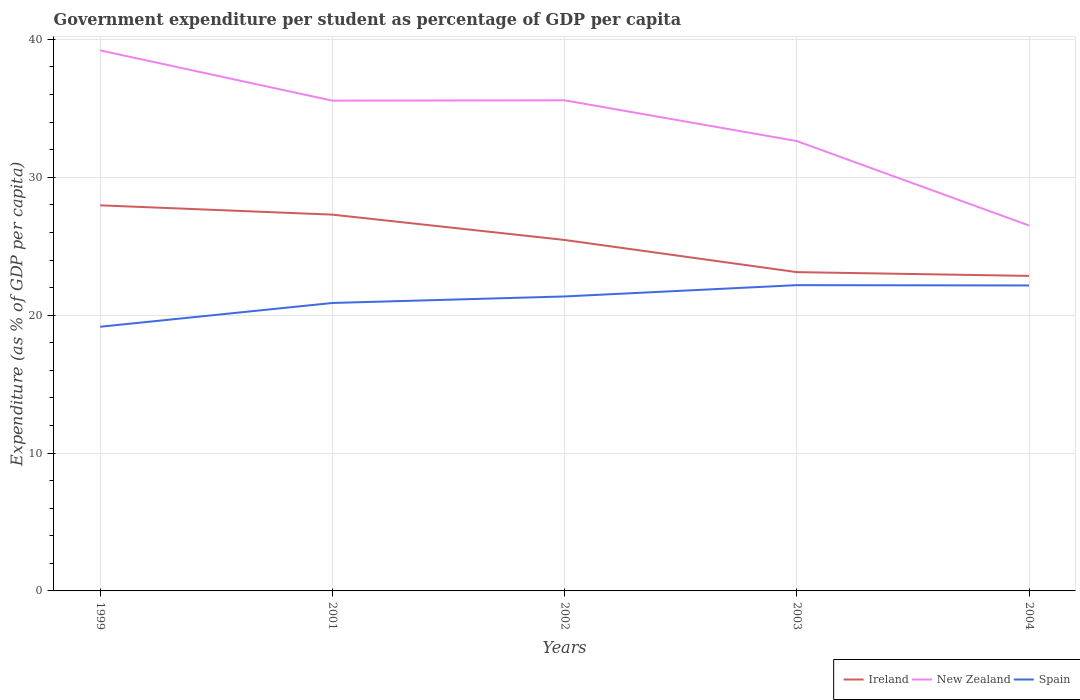How many different coloured lines are there?
Your response must be concise. 3. Across all years, what is the maximum percentage of expenditure per student in Ireland?
Ensure brevity in your answer.  22.85. In which year was the percentage of expenditure per student in Ireland maximum?
Provide a short and direct response. 2004. What is the total percentage of expenditure per student in Spain in the graph?
Ensure brevity in your answer.  0.02. What is the difference between the highest and the second highest percentage of expenditure per student in Spain?
Give a very brief answer. 3.02. What is the difference between the highest and the lowest percentage of expenditure per student in New Zealand?
Offer a very short reply. 3. Is the percentage of expenditure per student in New Zealand strictly greater than the percentage of expenditure per student in Spain over the years?
Keep it short and to the point. No. How many lines are there?
Ensure brevity in your answer.  3. What is the difference between two consecutive major ticks on the Y-axis?
Give a very brief answer. 10. Where does the legend appear in the graph?
Give a very brief answer. Bottom right. How many legend labels are there?
Make the answer very short. 3. What is the title of the graph?
Ensure brevity in your answer.  Government expenditure per student as percentage of GDP per capita. What is the label or title of the X-axis?
Your response must be concise. Years. What is the label or title of the Y-axis?
Your answer should be very brief. Expenditure (as % of GDP per capita). What is the Expenditure (as % of GDP per capita) in Ireland in 1999?
Make the answer very short. 27.97. What is the Expenditure (as % of GDP per capita) in New Zealand in 1999?
Provide a short and direct response. 39.2. What is the Expenditure (as % of GDP per capita) in Spain in 1999?
Offer a very short reply. 19.16. What is the Expenditure (as % of GDP per capita) of Ireland in 2001?
Ensure brevity in your answer.  27.29. What is the Expenditure (as % of GDP per capita) in New Zealand in 2001?
Make the answer very short. 35.56. What is the Expenditure (as % of GDP per capita) of Spain in 2001?
Your response must be concise. 20.88. What is the Expenditure (as % of GDP per capita) in Ireland in 2002?
Give a very brief answer. 25.45. What is the Expenditure (as % of GDP per capita) of New Zealand in 2002?
Provide a succinct answer. 35.58. What is the Expenditure (as % of GDP per capita) of Spain in 2002?
Offer a terse response. 21.36. What is the Expenditure (as % of GDP per capita) in Ireland in 2003?
Offer a very short reply. 23.12. What is the Expenditure (as % of GDP per capita) in New Zealand in 2003?
Provide a short and direct response. 32.63. What is the Expenditure (as % of GDP per capita) of Spain in 2003?
Keep it short and to the point. 22.18. What is the Expenditure (as % of GDP per capita) in Ireland in 2004?
Make the answer very short. 22.85. What is the Expenditure (as % of GDP per capita) in New Zealand in 2004?
Your answer should be compact. 26.5. What is the Expenditure (as % of GDP per capita) of Spain in 2004?
Your answer should be very brief. 22.16. Across all years, what is the maximum Expenditure (as % of GDP per capita) of Ireland?
Keep it short and to the point. 27.97. Across all years, what is the maximum Expenditure (as % of GDP per capita) in New Zealand?
Provide a succinct answer. 39.2. Across all years, what is the maximum Expenditure (as % of GDP per capita) of Spain?
Your answer should be compact. 22.18. Across all years, what is the minimum Expenditure (as % of GDP per capita) of Ireland?
Keep it short and to the point. 22.85. Across all years, what is the minimum Expenditure (as % of GDP per capita) in New Zealand?
Keep it short and to the point. 26.5. Across all years, what is the minimum Expenditure (as % of GDP per capita) of Spain?
Keep it short and to the point. 19.16. What is the total Expenditure (as % of GDP per capita) of Ireland in the graph?
Offer a very short reply. 126.68. What is the total Expenditure (as % of GDP per capita) of New Zealand in the graph?
Give a very brief answer. 169.47. What is the total Expenditure (as % of GDP per capita) in Spain in the graph?
Provide a succinct answer. 105.73. What is the difference between the Expenditure (as % of GDP per capita) in Ireland in 1999 and that in 2001?
Offer a terse response. 0.67. What is the difference between the Expenditure (as % of GDP per capita) of New Zealand in 1999 and that in 2001?
Provide a short and direct response. 3.65. What is the difference between the Expenditure (as % of GDP per capita) of Spain in 1999 and that in 2001?
Your answer should be compact. -1.72. What is the difference between the Expenditure (as % of GDP per capita) of Ireland in 1999 and that in 2002?
Your response must be concise. 2.51. What is the difference between the Expenditure (as % of GDP per capita) of New Zealand in 1999 and that in 2002?
Your answer should be very brief. 3.62. What is the difference between the Expenditure (as % of GDP per capita) of Spain in 1999 and that in 2002?
Offer a terse response. -2.2. What is the difference between the Expenditure (as % of GDP per capita) in Ireland in 1999 and that in 2003?
Offer a terse response. 4.84. What is the difference between the Expenditure (as % of GDP per capita) in New Zealand in 1999 and that in 2003?
Provide a short and direct response. 6.58. What is the difference between the Expenditure (as % of GDP per capita) in Spain in 1999 and that in 2003?
Provide a succinct answer. -3.02. What is the difference between the Expenditure (as % of GDP per capita) in Ireland in 1999 and that in 2004?
Make the answer very short. 5.12. What is the difference between the Expenditure (as % of GDP per capita) of New Zealand in 1999 and that in 2004?
Provide a short and direct response. 12.7. What is the difference between the Expenditure (as % of GDP per capita) in Spain in 1999 and that in 2004?
Provide a succinct answer. -2.99. What is the difference between the Expenditure (as % of GDP per capita) in Ireland in 2001 and that in 2002?
Your answer should be very brief. 1.84. What is the difference between the Expenditure (as % of GDP per capita) of New Zealand in 2001 and that in 2002?
Your response must be concise. -0.03. What is the difference between the Expenditure (as % of GDP per capita) in Spain in 2001 and that in 2002?
Offer a very short reply. -0.47. What is the difference between the Expenditure (as % of GDP per capita) of Ireland in 2001 and that in 2003?
Your answer should be very brief. 4.17. What is the difference between the Expenditure (as % of GDP per capita) in New Zealand in 2001 and that in 2003?
Offer a terse response. 2.93. What is the difference between the Expenditure (as % of GDP per capita) in Spain in 2001 and that in 2003?
Your answer should be compact. -1.29. What is the difference between the Expenditure (as % of GDP per capita) of Ireland in 2001 and that in 2004?
Provide a succinct answer. 4.44. What is the difference between the Expenditure (as % of GDP per capita) of New Zealand in 2001 and that in 2004?
Give a very brief answer. 9.06. What is the difference between the Expenditure (as % of GDP per capita) in Spain in 2001 and that in 2004?
Offer a very short reply. -1.27. What is the difference between the Expenditure (as % of GDP per capita) in Ireland in 2002 and that in 2003?
Provide a succinct answer. 2.33. What is the difference between the Expenditure (as % of GDP per capita) of New Zealand in 2002 and that in 2003?
Your answer should be compact. 2.96. What is the difference between the Expenditure (as % of GDP per capita) of Spain in 2002 and that in 2003?
Your response must be concise. -0.82. What is the difference between the Expenditure (as % of GDP per capita) in Ireland in 2002 and that in 2004?
Your answer should be compact. 2.61. What is the difference between the Expenditure (as % of GDP per capita) of New Zealand in 2002 and that in 2004?
Give a very brief answer. 9.08. What is the difference between the Expenditure (as % of GDP per capita) of Spain in 2002 and that in 2004?
Keep it short and to the point. -0.8. What is the difference between the Expenditure (as % of GDP per capita) of Ireland in 2003 and that in 2004?
Your response must be concise. 0.27. What is the difference between the Expenditure (as % of GDP per capita) of New Zealand in 2003 and that in 2004?
Ensure brevity in your answer.  6.12. What is the difference between the Expenditure (as % of GDP per capita) in Spain in 2003 and that in 2004?
Keep it short and to the point. 0.02. What is the difference between the Expenditure (as % of GDP per capita) of Ireland in 1999 and the Expenditure (as % of GDP per capita) of New Zealand in 2001?
Your answer should be very brief. -7.59. What is the difference between the Expenditure (as % of GDP per capita) of Ireland in 1999 and the Expenditure (as % of GDP per capita) of Spain in 2001?
Offer a terse response. 7.08. What is the difference between the Expenditure (as % of GDP per capita) of New Zealand in 1999 and the Expenditure (as % of GDP per capita) of Spain in 2001?
Your response must be concise. 18.32. What is the difference between the Expenditure (as % of GDP per capita) in Ireland in 1999 and the Expenditure (as % of GDP per capita) in New Zealand in 2002?
Your answer should be very brief. -7.62. What is the difference between the Expenditure (as % of GDP per capita) in Ireland in 1999 and the Expenditure (as % of GDP per capita) in Spain in 2002?
Your response must be concise. 6.61. What is the difference between the Expenditure (as % of GDP per capita) in New Zealand in 1999 and the Expenditure (as % of GDP per capita) in Spain in 2002?
Offer a terse response. 17.85. What is the difference between the Expenditure (as % of GDP per capita) of Ireland in 1999 and the Expenditure (as % of GDP per capita) of New Zealand in 2003?
Ensure brevity in your answer.  -4.66. What is the difference between the Expenditure (as % of GDP per capita) in Ireland in 1999 and the Expenditure (as % of GDP per capita) in Spain in 2003?
Your response must be concise. 5.79. What is the difference between the Expenditure (as % of GDP per capita) in New Zealand in 1999 and the Expenditure (as % of GDP per capita) in Spain in 2003?
Offer a very short reply. 17.03. What is the difference between the Expenditure (as % of GDP per capita) of Ireland in 1999 and the Expenditure (as % of GDP per capita) of New Zealand in 2004?
Keep it short and to the point. 1.46. What is the difference between the Expenditure (as % of GDP per capita) of Ireland in 1999 and the Expenditure (as % of GDP per capita) of Spain in 2004?
Make the answer very short. 5.81. What is the difference between the Expenditure (as % of GDP per capita) of New Zealand in 1999 and the Expenditure (as % of GDP per capita) of Spain in 2004?
Your response must be concise. 17.05. What is the difference between the Expenditure (as % of GDP per capita) in Ireland in 2001 and the Expenditure (as % of GDP per capita) in New Zealand in 2002?
Offer a terse response. -8.29. What is the difference between the Expenditure (as % of GDP per capita) of Ireland in 2001 and the Expenditure (as % of GDP per capita) of Spain in 2002?
Keep it short and to the point. 5.93. What is the difference between the Expenditure (as % of GDP per capita) of New Zealand in 2001 and the Expenditure (as % of GDP per capita) of Spain in 2002?
Provide a succinct answer. 14.2. What is the difference between the Expenditure (as % of GDP per capita) of Ireland in 2001 and the Expenditure (as % of GDP per capita) of New Zealand in 2003?
Give a very brief answer. -5.34. What is the difference between the Expenditure (as % of GDP per capita) in Ireland in 2001 and the Expenditure (as % of GDP per capita) in Spain in 2003?
Provide a short and direct response. 5.11. What is the difference between the Expenditure (as % of GDP per capita) of New Zealand in 2001 and the Expenditure (as % of GDP per capita) of Spain in 2003?
Provide a succinct answer. 13.38. What is the difference between the Expenditure (as % of GDP per capita) of Ireland in 2001 and the Expenditure (as % of GDP per capita) of New Zealand in 2004?
Keep it short and to the point. 0.79. What is the difference between the Expenditure (as % of GDP per capita) of Ireland in 2001 and the Expenditure (as % of GDP per capita) of Spain in 2004?
Provide a short and direct response. 5.14. What is the difference between the Expenditure (as % of GDP per capita) of New Zealand in 2001 and the Expenditure (as % of GDP per capita) of Spain in 2004?
Provide a succinct answer. 13.4. What is the difference between the Expenditure (as % of GDP per capita) in Ireland in 2002 and the Expenditure (as % of GDP per capita) in New Zealand in 2003?
Give a very brief answer. -7.17. What is the difference between the Expenditure (as % of GDP per capita) in Ireland in 2002 and the Expenditure (as % of GDP per capita) in Spain in 2003?
Offer a very short reply. 3.28. What is the difference between the Expenditure (as % of GDP per capita) of New Zealand in 2002 and the Expenditure (as % of GDP per capita) of Spain in 2003?
Provide a short and direct response. 13.41. What is the difference between the Expenditure (as % of GDP per capita) of Ireland in 2002 and the Expenditure (as % of GDP per capita) of New Zealand in 2004?
Provide a succinct answer. -1.05. What is the difference between the Expenditure (as % of GDP per capita) in Ireland in 2002 and the Expenditure (as % of GDP per capita) in Spain in 2004?
Ensure brevity in your answer.  3.3. What is the difference between the Expenditure (as % of GDP per capita) of New Zealand in 2002 and the Expenditure (as % of GDP per capita) of Spain in 2004?
Provide a short and direct response. 13.43. What is the difference between the Expenditure (as % of GDP per capita) in Ireland in 2003 and the Expenditure (as % of GDP per capita) in New Zealand in 2004?
Provide a short and direct response. -3.38. What is the difference between the Expenditure (as % of GDP per capita) of Ireland in 2003 and the Expenditure (as % of GDP per capita) of Spain in 2004?
Make the answer very short. 0.97. What is the difference between the Expenditure (as % of GDP per capita) of New Zealand in 2003 and the Expenditure (as % of GDP per capita) of Spain in 2004?
Provide a succinct answer. 10.47. What is the average Expenditure (as % of GDP per capita) of Ireland per year?
Give a very brief answer. 25.34. What is the average Expenditure (as % of GDP per capita) of New Zealand per year?
Offer a very short reply. 33.89. What is the average Expenditure (as % of GDP per capita) in Spain per year?
Make the answer very short. 21.15. In the year 1999, what is the difference between the Expenditure (as % of GDP per capita) in Ireland and Expenditure (as % of GDP per capita) in New Zealand?
Your answer should be very brief. -11.24. In the year 1999, what is the difference between the Expenditure (as % of GDP per capita) of Ireland and Expenditure (as % of GDP per capita) of Spain?
Provide a succinct answer. 8.81. In the year 1999, what is the difference between the Expenditure (as % of GDP per capita) of New Zealand and Expenditure (as % of GDP per capita) of Spain?
Offer a very short reply. 20.04. In the year 2001, what is the difference between the Expenditure (as % of GDP per capita) of Ireland and Expenditure (as % of GDP per capita) of New Zealand?
Your response must be concise. -8.27. In the year 2001, what is the difference between the Expenditure (as % of GDP per capita) in Ireland and Expenditure (as % of GDP per capita) in Spain?
Ensure brevity in your answer.  6.41. In the year 2001, what is the difference between the Expenditure (as % of GDP per capita) of New Zealand and Expenditure (as % of GDP per capita) of Spain?
Your answer should be very brief. 14.67. In the year 2002, what is the difference between the Expenditure (as % of GDP per capita) of Ireland and Expenditure (as % of GDP per capita) of New Zealand?
Ensure brevity in your answer.  -10.13. In the year 2002, what is the difference between the Expenditure (as % of GDP per capita) in Ireland and Expenditure (as % of GDP per capita) in Spain?
Give a very brief answer. 4.1. In the year 2002, what is the difference between the Expenditure (as % of GDP per capita) of New Zealand and Expenditure (as % of GDP per capita) of Spain?
Your answer should be compact. 14.23. In the year 2003, what is the difference between the Expenditure (as % of GDP per capita) of Ireland and Expenditure (as % of GDP per capita) of New Zealand?
Give a very brief answer. -9.51. In the year 2003, what is the difference between the Expenditure (as % of GDP per capita) of Ireland and Expenditure (as % of GDP per capita) of Spain?
Provide a succinct answer. 0.94. In the year 2003, what is the difference between the Expenditure (as % of GDP per capita) of New Zealand and Expenditure (as % of GDP per capita) of Spain?
Provide a succinct answer. 10.45. In the year 2004, what is the difference between the Expenditure (as % of GDP per capita) of Ireland and Expenditure (as % of GDP per capita) of New Zealand?
Your answer should be compact. -3.65. In the year 2004, what is the difference between the Expenditure (as % of GDP per capita) in Ireland and Expenditure (as % of GDP per capita) in Spain?
Keep it short and to the point. 0.69. In the year 2004, what is the difference between the Expenditure (as % of GDP per capita) in New Zealand and Expenditure (as % of GDP per capita) in Spain?
Offer a very short reply. 4.35. What is the ratio of the Expenditure (as % of GDP per capita) in Ireland in 1999 to that in 2001?
Your response must be concise. 1.02. What is the ratio of the Expenditure (as % of GDP per capita) of New Zealand in 1999 to that in 2001?
Your answer should be compact. 1.1. What is the ratio of the Expenditure (as % of GDP per capita) of Spain in 1999 to that in 2001?
Your response must be concise. 0.92. What is the ratio of the Expenditure (as % of GDP per capita) of Ireland in 1999 to that in 2002?
Your answer should be very brief. 1.1. What is the ratio of the Expenditure (as % of GDP per capita) in New Zealand in 1999 to that in 2002?
Offer a terse response. 1.1. What is the ratio of the Expenditure (as % of GDP per capita) of Spain in 1999 to that in 2002?
Your answer should be very brief. 0.9. What is the ratio of the Expenditure (as % of GDP per capita) in Ireland in 1999 to that in 2003?
Your answer should be compact. 1.21. What is the ratio of the Expenditure (as % of GDP per capita) of New Zealand in 1999 to that in 2003?
Ensure brevity in your answer.  1.2. What is the ratio of the Expenditure (as % of GDP per capita) in Spain in 1999 to that in 2003?
Keep it short and to the point. 0.86. What is the ratio of the Expenditure (as % of GDP per capita) in Ireland in 1999 to that in 2004?
Provide a short and direct response. 1.22. What is the ratio of the Expenditure (as % of GDP per capita) in New Zealand in 1999 to that in 2004?
Ensure brevity in your answer.  1.48. What is the ratio of the Expenditure (as % of GDP per capita) in Spain in 1999 to that in 2004?
Offer a very short reply. 0.86. What is the ratio of the Expenditure (as % of GDP per capita) in Ireland in 2001 to that in 2002?
Make the answer very short. 1.07. What is the ratio of the Expenditure (as % of GDP per capita) in New Zealand in 2001 to that in 2002?
Provide a succinct answer. 1. What is the ratio of the Expenditure (as % of GDP per capita) in Spain in 2001 to that in 2002?
Provide a succinct answer. 0.98. What is the ratio of the Expenditure (as % of GDP per capita) of Ireland in 2001 to that in 2003?
Offer a terse response. 1.18. What is the ratio of the Expenditure (as % of GDP per capita) in New Zealand in 2001 to that in 2003?
Your answer should be very brief. 1.09. What is the ratio of the Expenditure (as % of GDP per capita) in Spain in 2001 to that in 2003?
Ensure brevity in your answer.  0.94. What is the ratio of the Expenditure (as % of GDP per capita) of Ireland in 2001 to that in 2004?
Offer a very short reply. 1.19. What is the ratio of the Expenditure (as % of GDP per capita) in New Zealand in 2001 to that in 2004?
Offer a very short reply. 1.34. What is the ratio of the Expenditure (as % of GDP per capita) in Spain in 2001 to that in 2004?
Make the answer very short. 0.94. What is the ratio of the Expenditure (as % of GDP per capita) in Ireland in 2002 to that in 2003?
Your answer should be compact. 1.1. What is the ratio of the Expenditure (as % of GDP per capita) in New Zealand in 2002 to that in 2003?
Give a very brief answer. 1.09. What is the ratio of the Expenditure (as % of GDP per capita) of Spain in 2002 to that in 2003?
Ensure brevity in your answer.  0.96. What is the ratio of the Expenditure (as % of GDP per capita) in Ireland in 2002 to that in 2004?
Make the answer very short. 1.11. What is the ratio of the Expenditure (as % of GDP per capita) in New Zealand in 2002 to that in 2004?
Your answer should be very brief. 1.34. What is the ratio of the Expenditure (as % of GDP per capita) in Ireland in 2003 to that in 2004?
Keep it short and to the point. 1.01. What is the ratio of the Expenditure (as % of GDP per capita) in New Zealand in 2003 to that in 2004?
Your answer should be very brief. 1.23. What is the difference between the highest and the second highest Expenditure (as % of GDP per capita) in Ireland?
Provide a short and direct response. 0.67. What is the difference between the highest and the second highest Expenditure (as % of GDP per capita) in New Zealand?
Provide a succinct answer. 3.62. What is the difference between the highest and the second highest Expenditure (as % of GDP per capita) of Spain?
Give a very brief answer. 0.02. What is the difference between the highest and the lowest Expenditure (as % of GDP per capita) of Ireland?
Provide a succinct answer. 5.12. What is the difference between the highest and the lowest Expenditure (as % of GDP per capita) of New Zealand?
Provide a short and direct response. 12.7. What is the difference between the highest and the lowest Expenditure (as % of GDP per capita) of Spain?
Keep it short and to the point. 3.02. 